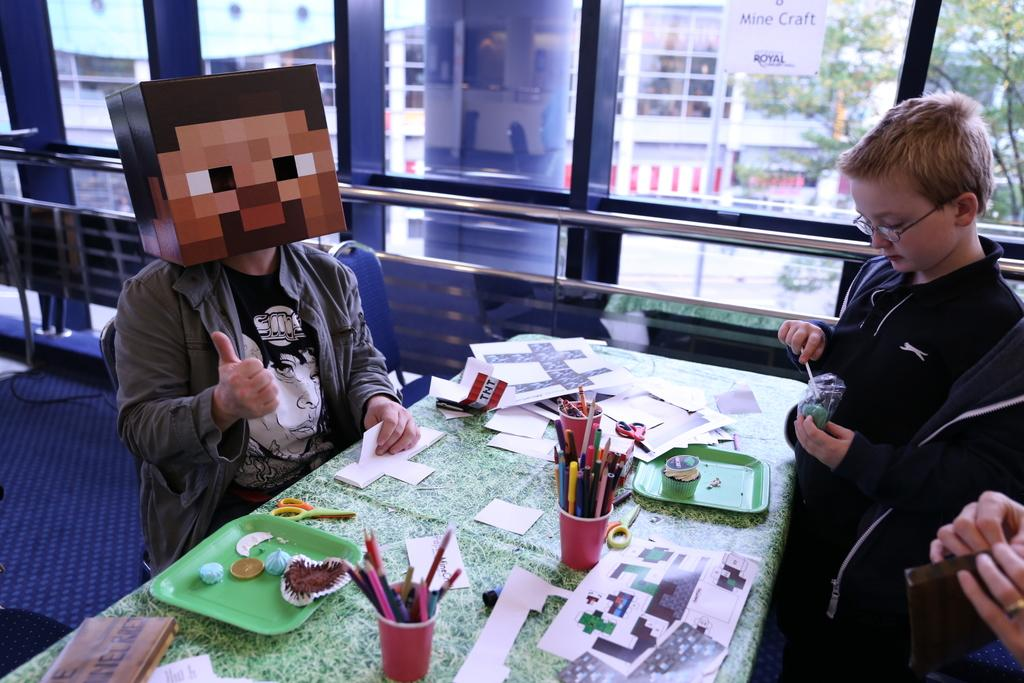What is the position of the man in the image? There is a man seated on a chair and another man standing in the image. What objects are on the table in the image? There are pencils and papers on the table in the image. What can be seen through the window in the image? There is a building and a tree visible through the window in the image. What type of tent can be seen in the image? There is no tent present in the image. How many blades are visible in the image? There is no blade present in the image. 